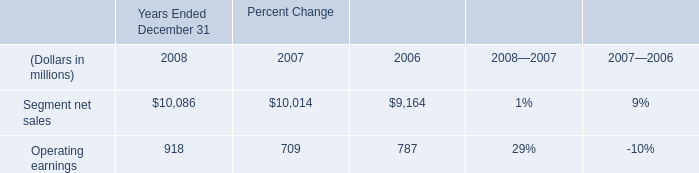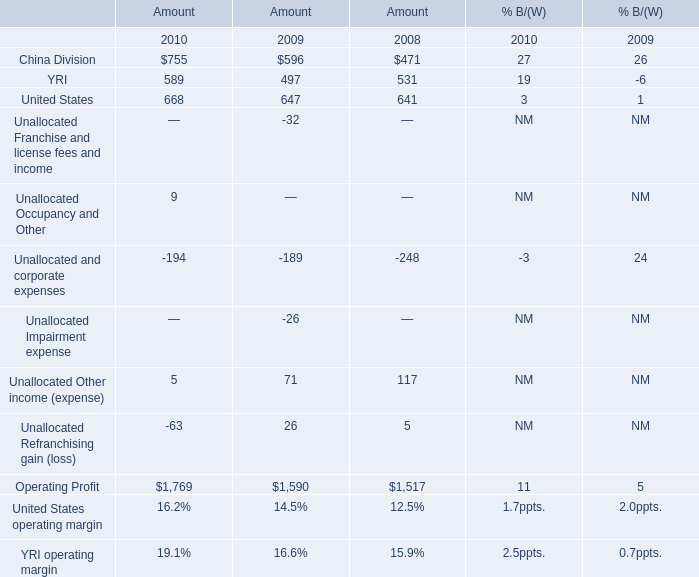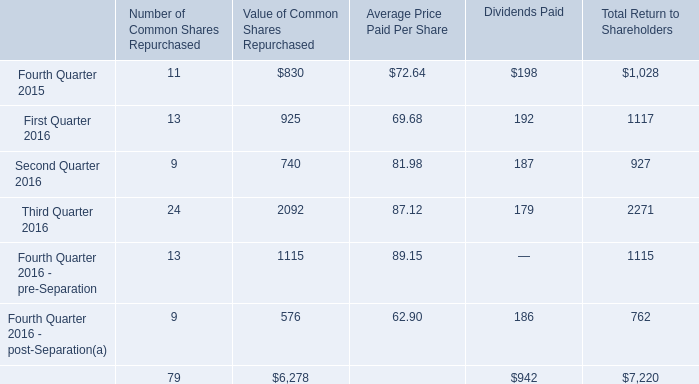What is the average amount of Operating Profit of Amount 2010, and Third Quarter 2016 of Value of Common Shares Repurchased ? 
Computations: ((1769.0 + 2092.0) / 2)
Answer: 1930.5. Does YRI keeps increasing each year between 2009 and 2010 for amount? 
Answer: yes. 